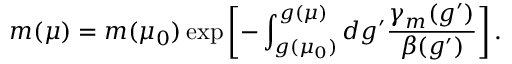<formula> <loc_0><loc_0><loc_500><loc_500>m ( \mu ) = m ( \mu _ { 0 } ) \exp \left [ - \int _ { g ( \mu _ { 0 } ) } ^ { g ( \mu ) } { d g ^ { \prime } \frac { \gamma _ { m } ( g ^ { \prime } ) } { \beta ( g ^ { \prime } ) } } \right ] .</formula> 